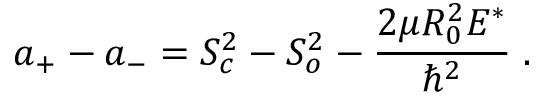Convert formula to latex. <formula><loc_0><loc_0><loc_500><loc_500>a _ { + } - a _ { - } = S _ { c } ^ { 2 } - S _ { o } ^ { 2 } - \frac { 2 \mu R _ { 0 } ^ { 2 } E ^ { * } } { \hbar { ^ } { 2 } } \, .</formula> 